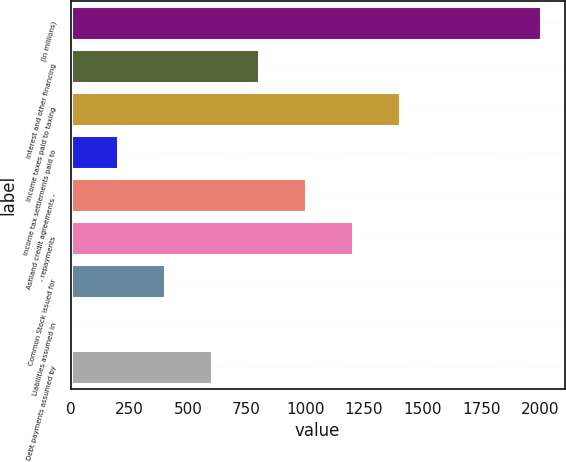<chart> <loc_0><loc_0><loc_500><loc_500><bar_chart><fcel>(In millions)<fcel>Interest and other financing<fcel>Income taxes paid to taxing<fcel>Income tax settlements paid to<fcel>Ashland credit agreements -<fcel>- repayments<fcel>Common Stock issued for<fcel>Liabilities assumed in<fcel>Debt payments assumed by<nl><fcel>2004<fcel>802.2<fcel>1403.1<fcel>201.3<fcel>1002.5<fcel>1202.8<fcel>401.6<fcel>1<fcel>601.9<nl></chart> 